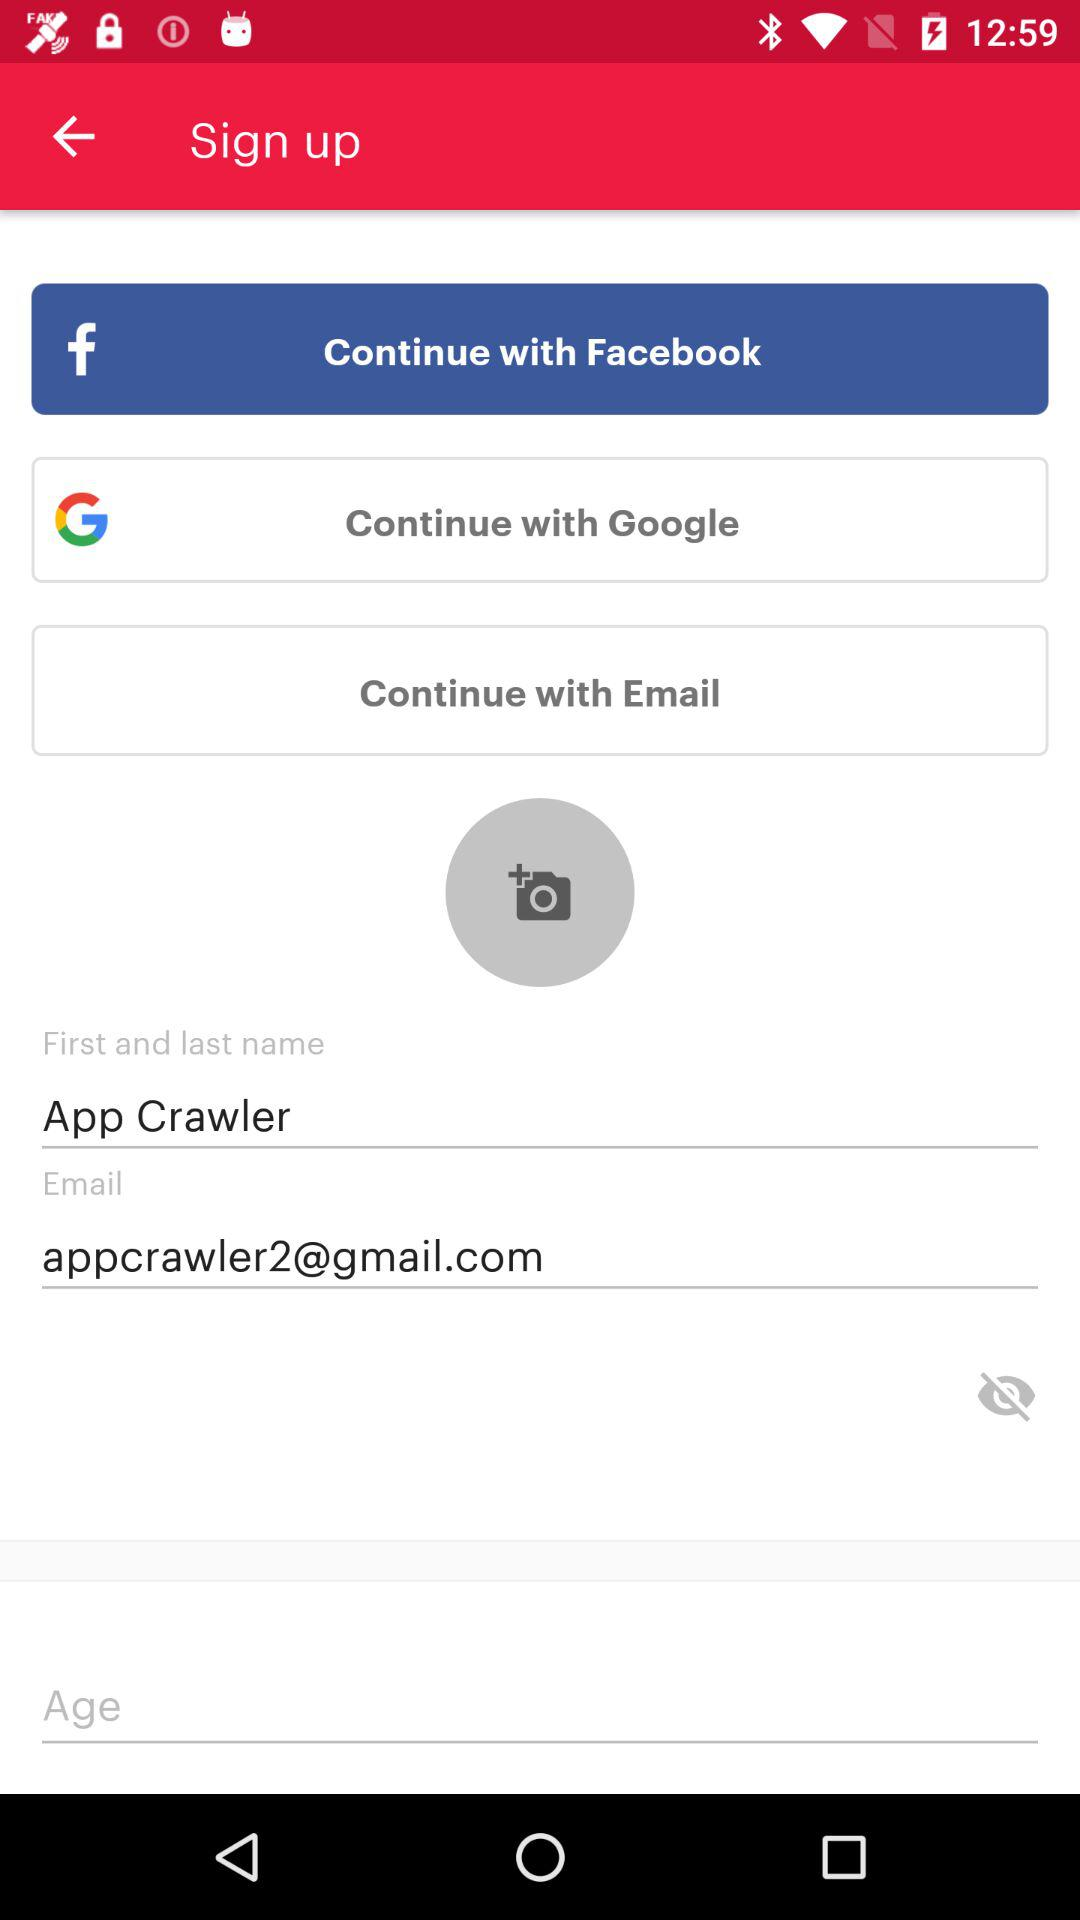How many ways can you sign up for an account?
Answer the question using a single word or phrase. 3 